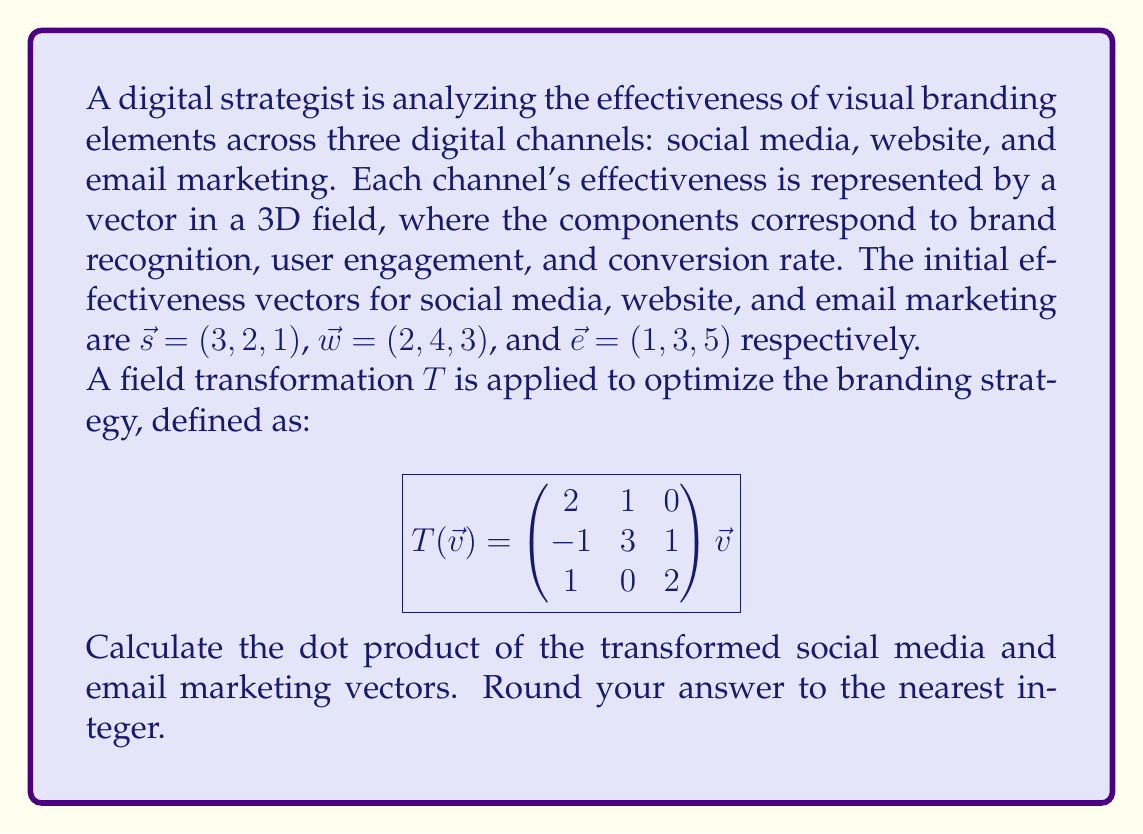Give your solution to this math problem. To solve this problem, we need to follow these steps:

1) First, apply the field transformation $T$ to both the social media vector $\vec{s}$ and the email marketing vector $\vec{e}$.

2) For social media $\vec{s} = (3, 2, 1)$:
   $$T(\vec{s}) = \begin{pmatrix}
   2 & 1 & 0 \\
   -1 & 3 & 1 \\
   1 & 0 & 2
   \end{pmatrix} \begin{pmatrix} 3 \\ 2 \\ 1 \end{pmatrix}$$

   $$= \begin{pmatrix}
   (2 \cdot 3 + 1 \cdot 2 + 0 \cdot 1) \\
   (-1 \cdot 3 + 3 \cdot 2 + 1 \cdot 1) \\
   (1 \cdot 3 + 0 \cdot 2 + 2 \cdot 1)
   \end{pmatrix} = \begin{pmatrix} 8 \\ 4 \\ 5 \end{pmatrix}$$

3) For email marketing $\vec{e} = (1, 3, 5)$:
   $$T(\vec{e}) = \begin{pmatrix}
   2 & 1 & 0 \\
   -1 & 3 & 1 \\
   1 & 0 & 2
   \end{pmatrix} \begin{pmatrix} 1 \\ 3 \\ 5 \end{pmatrix}$$

   $$= \begin{pmatrix}
   (2 \cdot 1 + 1 \cdot 3 + 0 \cdot 5) \\
   (-1 \cdot 1 + 3 \cdot 3 + 1 \cdot 5) \\
   (1 \cdot 1 + 0 \cdot 3 + 2 \cdot 5)
   \end{pmatrix} = \begin{pmatrix} 5 \\ 13 \\ 11 \end{pmatrix}$$

4) Now, calculate the dot product of these transformed vectors:
   $$(8, 4, 5) \cdot (5, 13, 11) = 8 \cdot 5 + 4 \cdot 13 + 5 \cdot 11$$
   $$= 40 + 52 + 55 = 147$$

5) Rounding to the nearest integer: 147
Answer: 147 